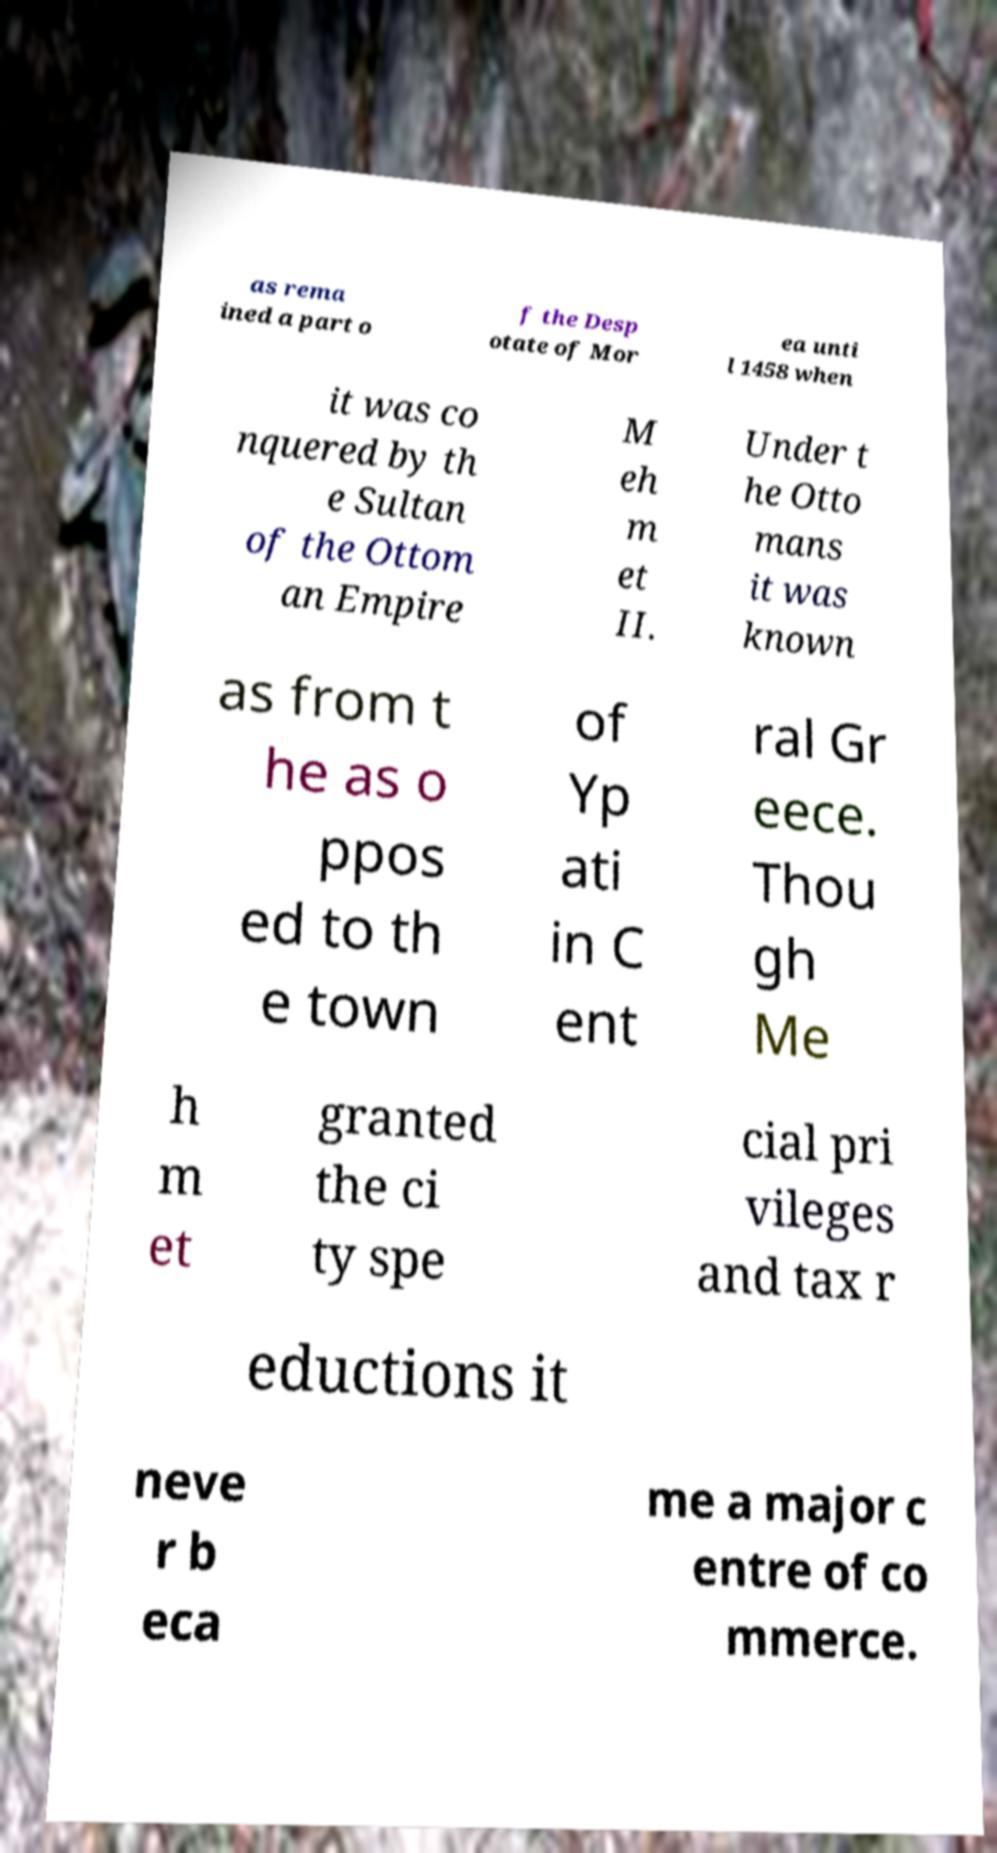Can you read and provide the text displayed in the image?This photo seems to have some interesting text. Can you extract and type it out for me? as rema ined a part o f the Desp otate of Mor ea unti l 1458 when it was co nquered by th e Sultan of the Ottom an Empire M eh m et II. Under t he Otto mans it was known as from t he as o ppos ed to th e town of Yp ati in C ent ral Gr eece. Thou gh Me h m et granted the ci ty spe cial pri vileges and tax r eductions it neve r b eca me a major c entre of co mmerce. 